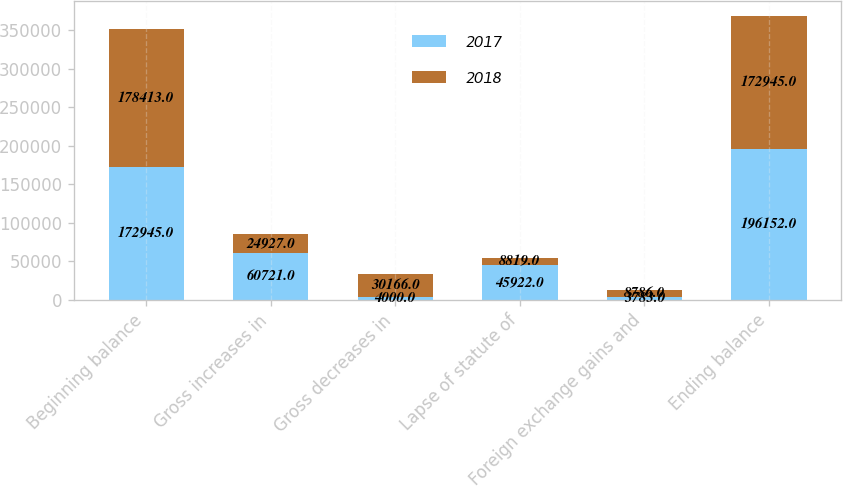Convert chart. <chart><loc_0><loc_0><loc_500><loc_500><stacked_bar_chart><ecel><fcel>Beginning balance<fcel>Gross increases in<fcel>Gross decreases in<fcel>Lapse of statute of<fcel>Foreign exchange gains and<fcel>Ending balance<nl><fcel>2017<fcel>172945<fcel>60721<fcel>4000<fcel>45922<fcel>3783<fcel>196152<nl><fcel>2018<fcel>178413<fcel>24927<fcel>30166<fcel>8819<fcel>8786<fcel>172945<nl></chart> 